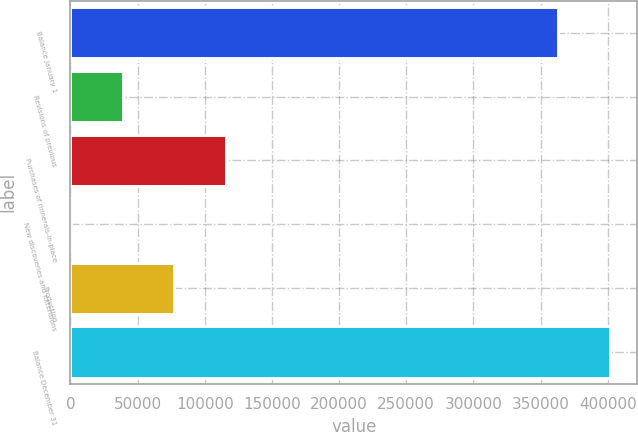Convert chart. <chart><loc_0><loc_0><loc_500><loc_500><bar_chart><fcel>Balance January 1<fcel>Revisions of previous<fcel>Purchases of minerals-in-place<fcel>New discoveries and extensions<fcel>Production<fcel>Balance December 31<nl><fcel>363257<fcel>38779.6<fcel>115889<fcel>225<fcel>77334.2<fcel>401812<nl></chart> 